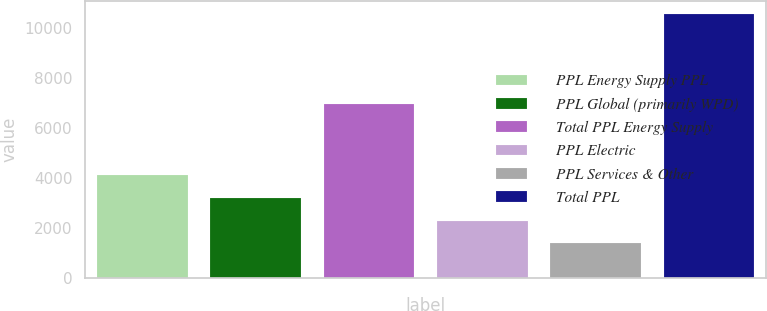Convert chart. <chart><loc_0><loc_0><loc_500><loc_500><bar_chart><fcel>PPL Energy Supply PPL<fcel>PPL Global (primarily WPD)<fcel>Total PPL Energy Supply<fcel>PPL Electric<fcel>PPL Services & Other<fcel>Total PPL<nl><fcel>4133.6<fcel>3216.4<fcel>6950<fcel>2299.2<fcel>1382<fcel>10554<nl></chart> 